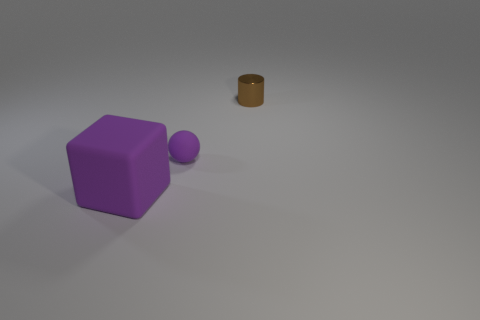Subtract all balls. How many objects are left? 2 Add 3 big cubes. How many big cubes exist? 4 Add 2 large blue shiny things. How many objects exist? 5 Subtract 0 blue blocks. How many objects are left? 3 Subtract all blue cubes. Subtract all gray cylinders. How many cubes are left? 1 Subtract all brown cubes. How many blue cylinders are left? 0 Subtract all big cylinders. Subtract all small brown objects. How many objects are left? 2 Add 2 brown objects. How many brown objects are left? 3 